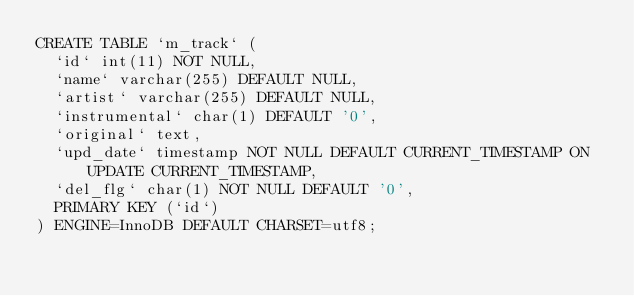<code> <loc_0><loc_0><loc_500><loc_500><_SQL_>CREATE TABLE `m_track` (
  `id` int(11) NOT NULL,
  `name` varchar(255) DEFAULT NULL,
  `artist` varchar(255) DEFAULT NULL,
  `instrumental` char(1) DEFAULT '0',
  `original` text,
  `upd_date` timestamp NOT NULL DEFAULT CURRENT_TIMESTAMP ON UPDATE CURRENT_TIMESTAMP,
  `del_flg` char(1) NOT NULL DEFAULT '0',
  PRIMARY KEY (`id`)
) ENGINE=InnoDB DEFAULT CHARSET=utf8;
</code> 